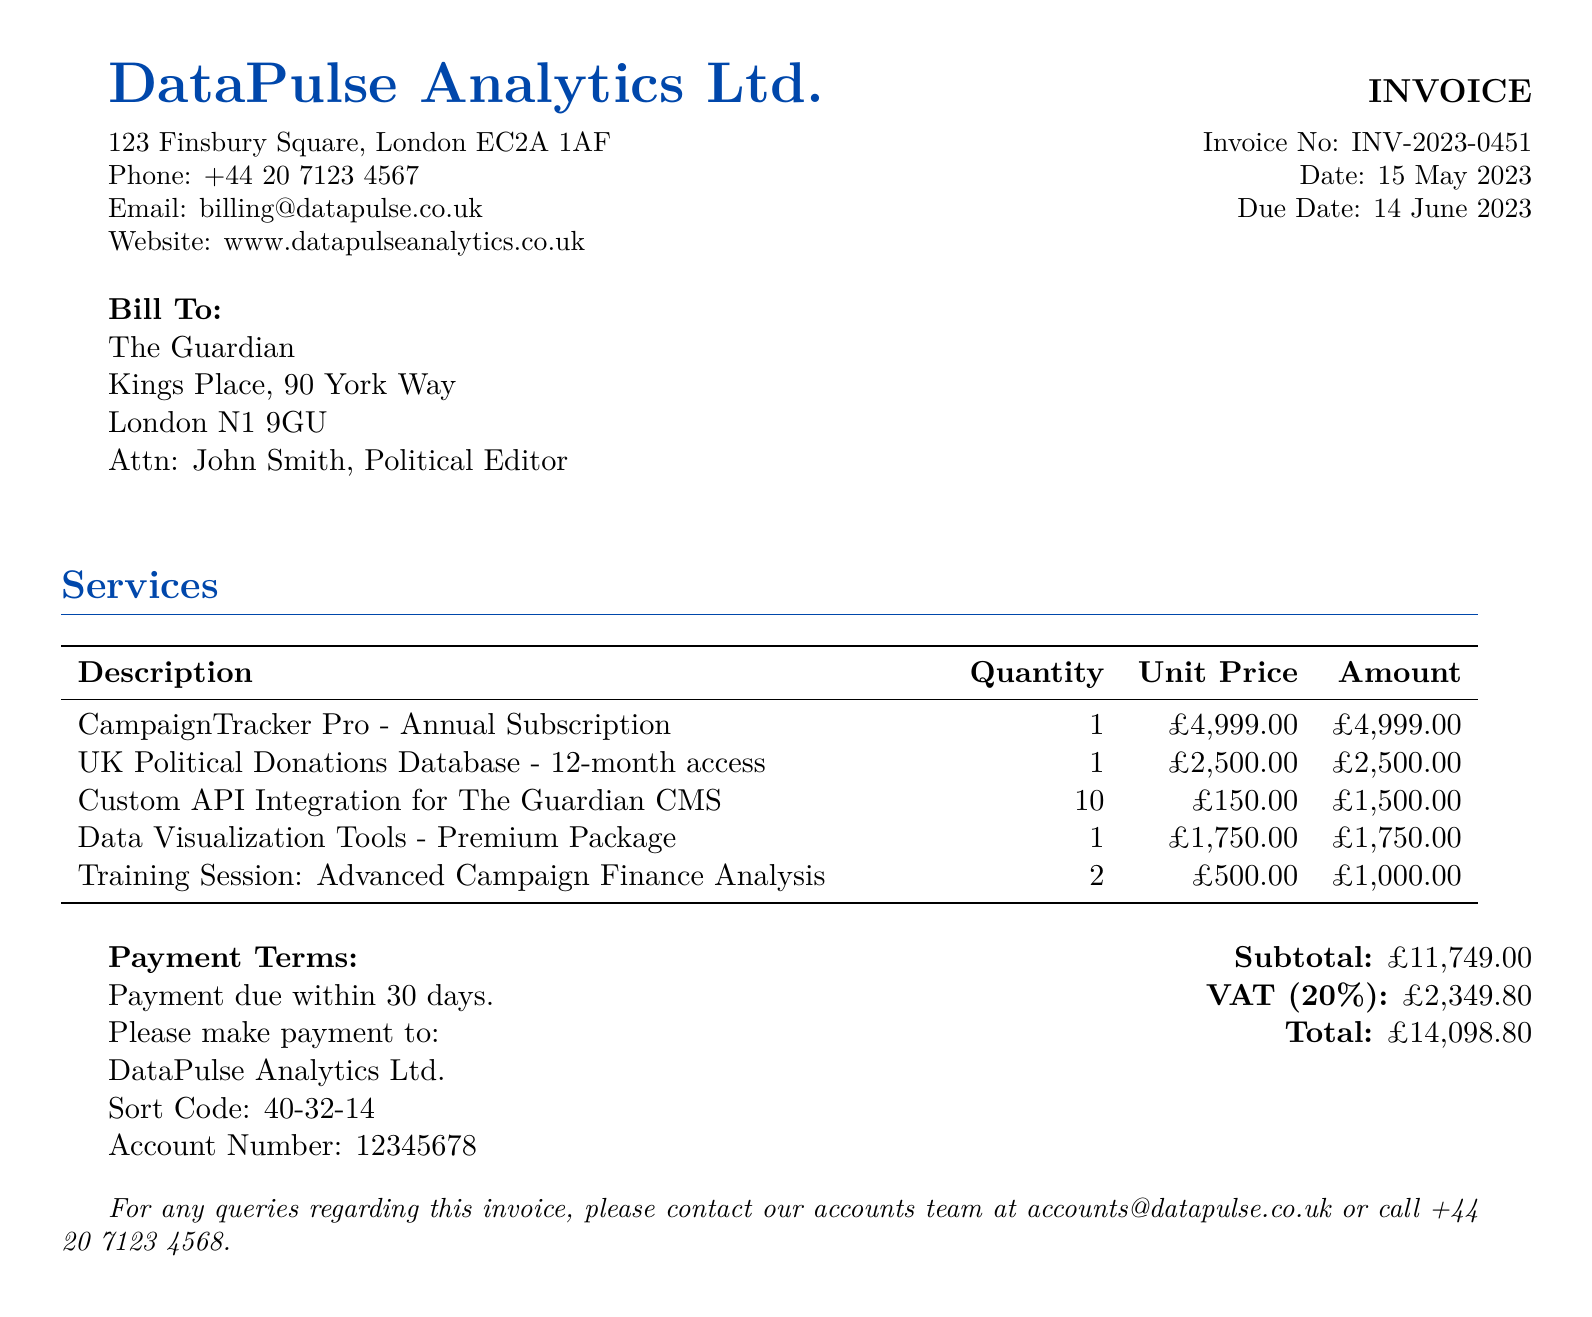what is the invoice number? The invoice number is listed in the top section of the document next to 'Invoice No'.
Answer: INV-2023-0451 who is the bill addressed to? The bill is addressed to 'The Guardian', as indicated under the 'Bill To' section.
Answer: The Guardian what is the due date for payment? The due date is specified in the invoice section and indicates when payment should be made.
Answer: 14 June 2023 how much is the VAT charged? The VAT amount is detailed toward the end of the invoice, specifically labeled next to 'VAT (20%)'.
Answer: £2,349.80 what is the total amount due? The total amount due is the sum of the subtotal and VAT, explicitly stated in the document.
Answer: £14,098.80 how many training sessions are included? The number of training sessions is specified in the services table for 'Training Session: Advanced Campaign Finance Analysis'.
Answer: 2 which service has the highest cost? The service with the highest cost can be identified from the services table by looking for the highest unit price.
Answer: CampaignTracker Pro - Annual Subscription what payment terms are specified? The payment terms detail when payment must be made and can be found in the document.
Answer: Payment due within 30 days which custom service is provided for integration? The specific custom service for integration is mentioned in the services table under custom API offerings.
Answer: Custom API Integration for The Guardian CMS 